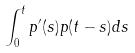<formula> <loc_0><loc_0><loc_500><loc_500>\int _ { 0 } ^ { t } p ^ { \prime } ( s ) p ( t - s ) d s</formula> 